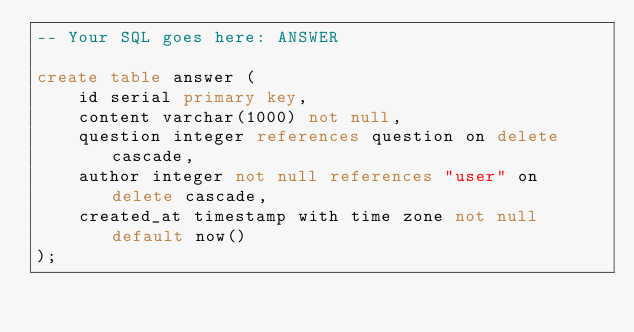Convert code to text. <code><loc_0><loc_0><loc_500><loc_500><_SQL_>-- Your SQL goes here: ANSWER

create table answer (
    id serial primary key,
    content varchar(1000) not null,
    question integer references question on delete cascade,
    author integer not null references "user" on delete cascade,
    created_at timestamp with time zone not null default now()
);</code> 